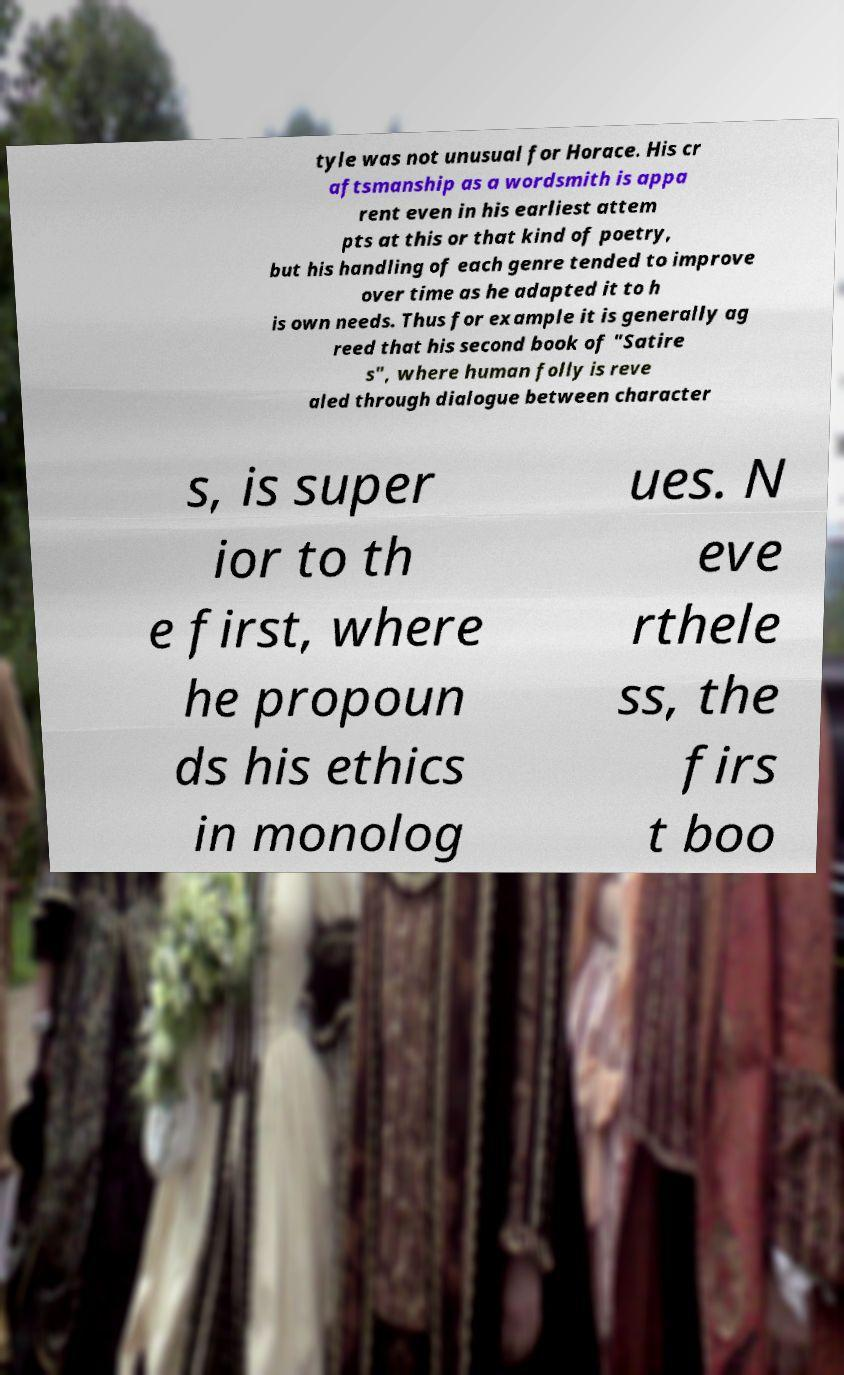There's text embedded in this image that I need extracted. Can you transcribe it verbatim? tyle was not unusual for Horace. His cr aftsmanship as a wordsmith is appa rent even in his earliest attem pts at this or that kind of poetry, but his handling of each genre tended to improve over time as he adapted it to h is own needs. Thus for example it is generally ag reed that his second book of "Satire s", where human folly is reve aled through dialogue between character s, is super ior to th e first, where he propoun ds his ethics in monolog ues. N eve rthele ss, the firs t boo 